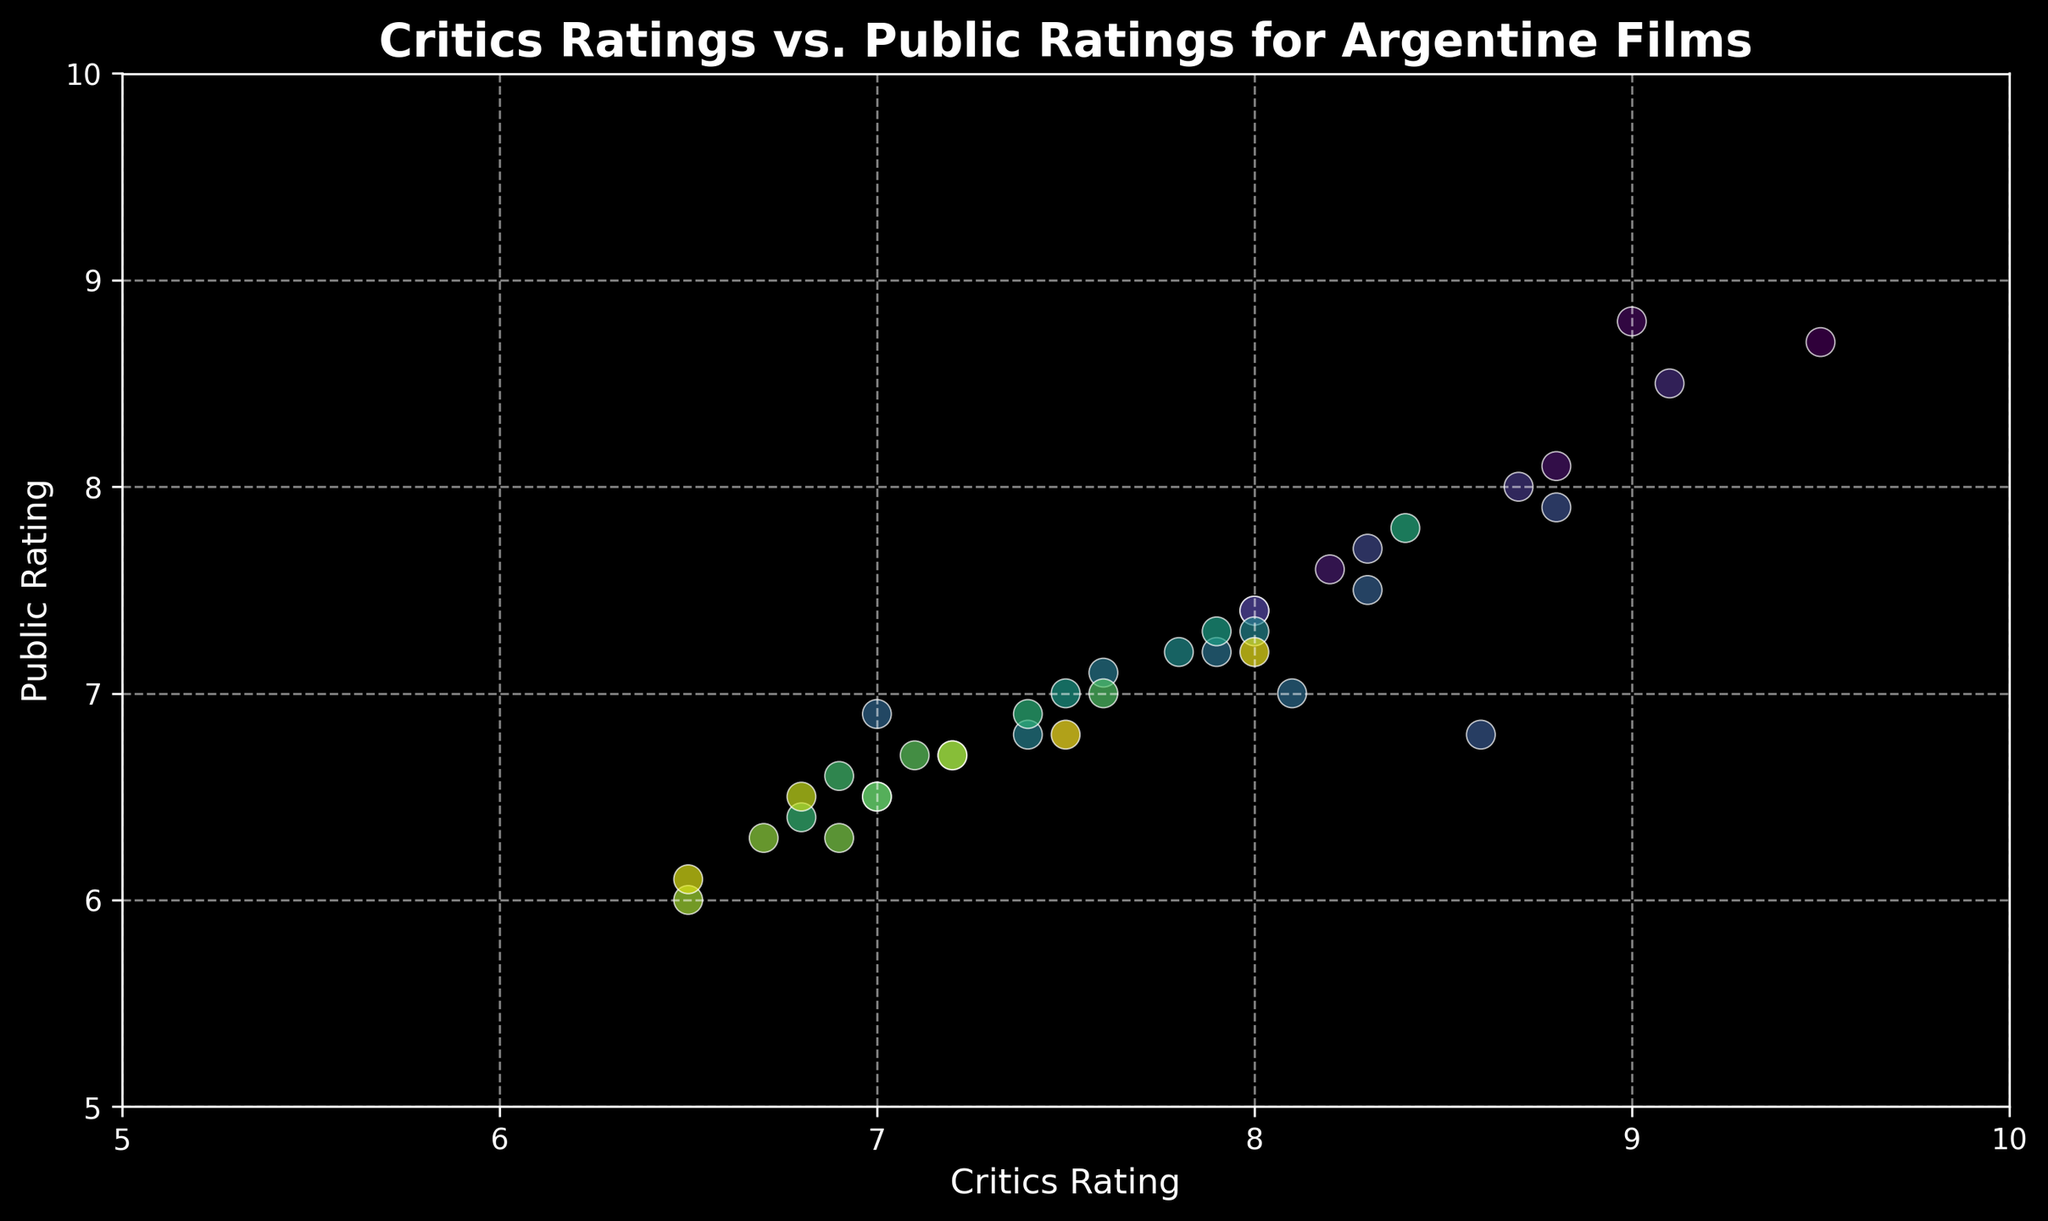What is the general trend between Critics' ratings and Public ratings in the plot? By looking at the scatter plot, we can observe the overall correlation between Critics' ratings and Public ratings. If the points generally move from the bottom left to the top right, it indicates a positive correlation.
Answer: Positive correlation Which film has the highest Critics' rating, and what is its corresponding Public rating? Locate the point farthest to the right on the x-axis and identify it. According to the data, "El Secreto de Sus Ojos" has the highest Critics' rating at 9.5, and its corresponding Public rating is 8.7.
Answer: El Secreto de Sus Ojos, 8.7 Are there any films with a Critics' rating lower than 7.0? If so, name one. Look for points on the scatter plot that are positioned to the left of the 7.0 mark on the x-axis. From the data, "Desearás al hombre de tu hermana" has a Critics' rating of 6.5.
Answer: Desearás al hombre de tu hermana What's the difference between the Critics' rating and Public rating for "Relatos Salvajes"? Locate the point representing "Relatos Salvajes" and compute the difference: Critics' rating (9.0) - Public rating (8.8). The difference is 0.2.
Answer: 0.2 Is there a film where both Critics' and Public ratings are close to the midpoint value of 7.0? If so, name the film. Look for points that hover close to the (7.0, 7.0) coordinate. One such film is "Abzurdah" with a Critics' rating of 7.0 and a Public rating of 6.9.
Answer: Abzurdah Which film has the largest discrepancy between Critics' rating and Public rating? Analyze the vertical distance between the x-axis value (Critics' rating) and the y-axis value (Public rating) for each point. "La Ciénaga" shows one of the largest discrepancies with a Critics' rating of 8.6 and Public rating of 6.8, resulting in a difference of 1.8.
Answer: La Ciénaga Are there any films with a higher Public rating than Critics' rating? Name one, if any. Look for points where the y-coordinate (Public rating) is higher than the x-coordinate (Critics' rating). From the data, "Relatos Salvajes" has a Public rating (8.8) slightly higher than its Critics' rating (9.0).
Answer: None What's the average Public rating for films with a Critics' rating above 9.0? Identify films with a Critics' rating above 9.0: "El Secreto de Sus Ojos" (8.7) and "La Historia Oficial" (8.5). The average Public rating is the sum of these ratings divided by the number of films, (8.7 + 8.5) / 2 = 8.6.
Answer: 8.6 